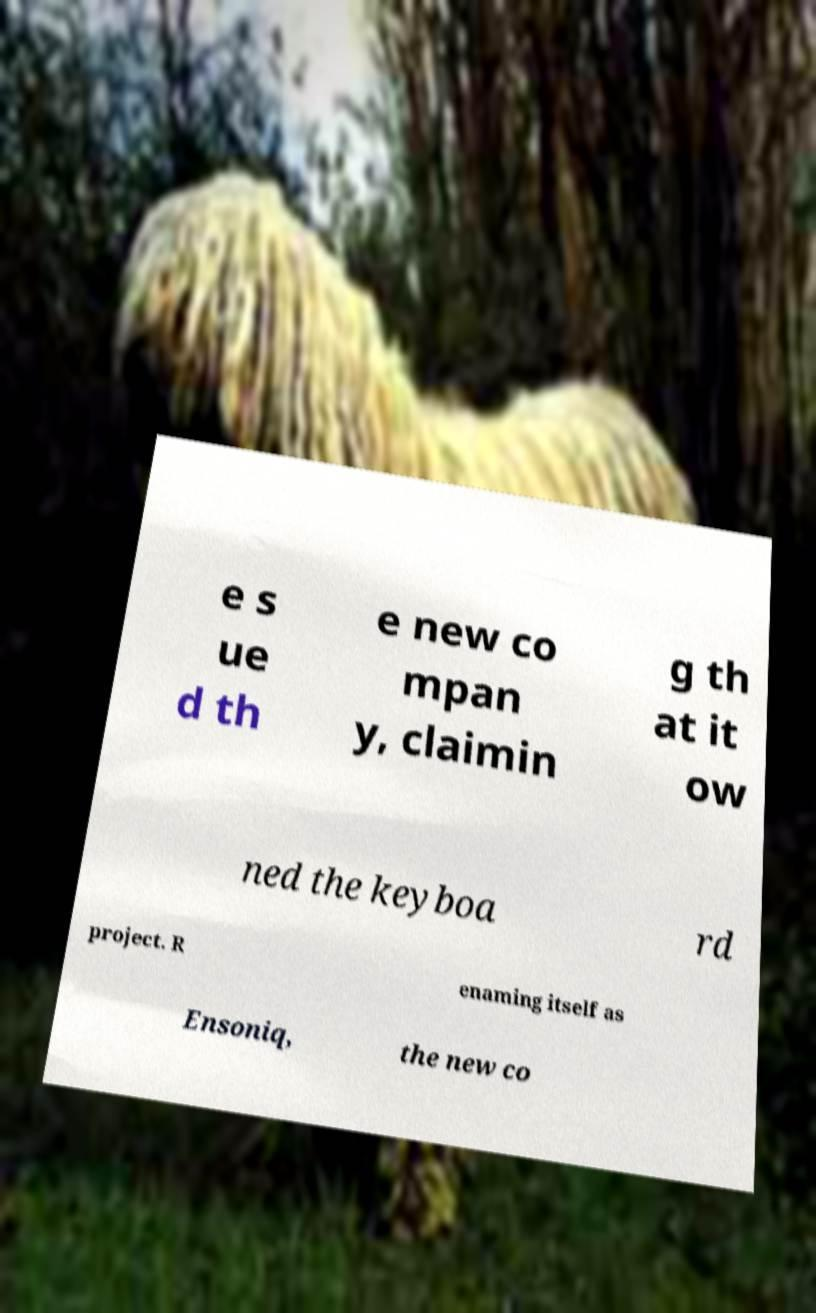I need the written content from this picture converted into text. Can you do that? e s ue d th e new co mpan y, claimin g th at it ow ned the keyboa rd project. R enaming itself as Ensoniq, the new co 